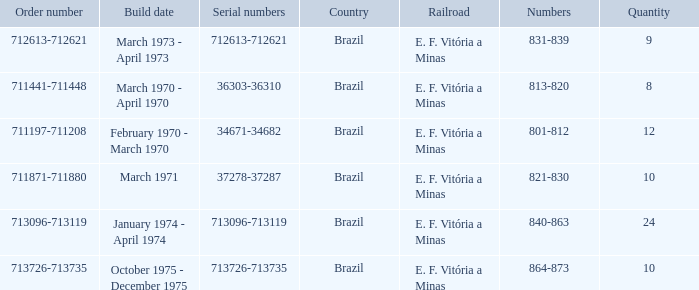What are the numbers for the order number 713096-713119? 840-863. 